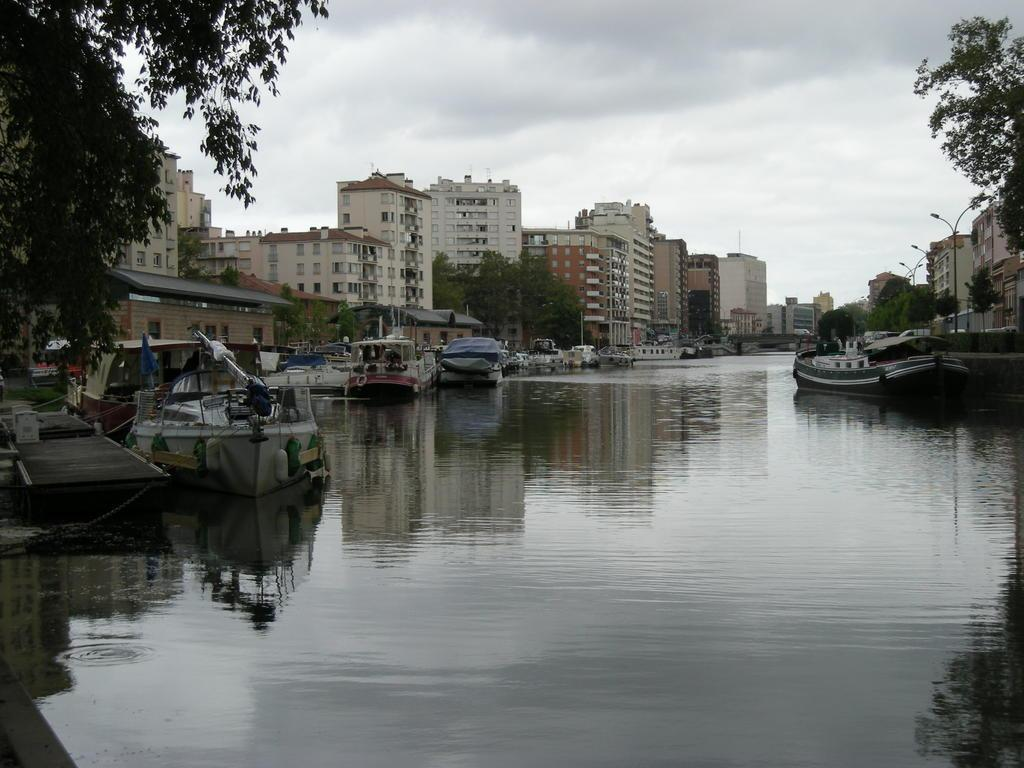What is on the water in the image? There are boats on the water in the image. What type of structures can be seen in the image? There are buildings in the image. What other natural elements are present in the image? There are trees in the image. What are the poles used for in the image? The poles are likely used for supporting lights or other structures in the image. What can be seen in the background of the image? The sky is visible in the background of the image. What type of friction can be seen between the brother and the calendar in the image? There is no brother or calendar present in the image; it features boats on the water, buildings, trees, poles, lights, and the sky. 